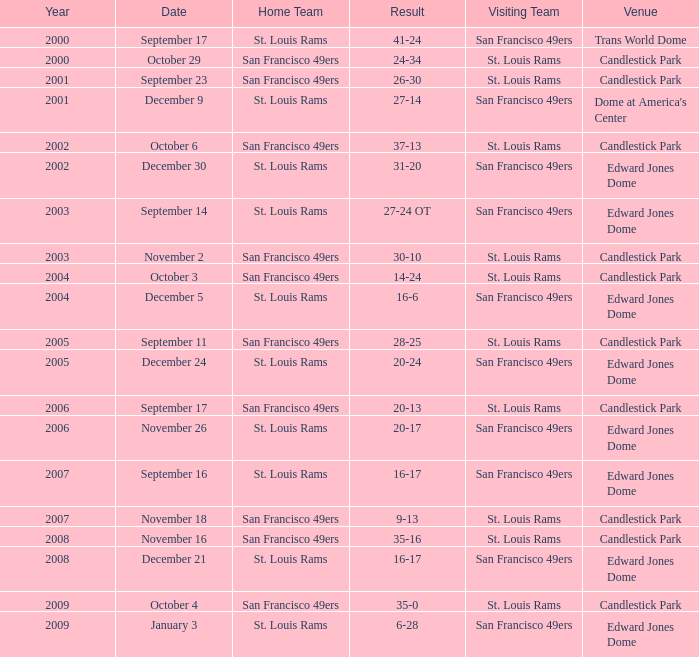What Date after 2007 had the San Francisco 49ers as the Visiting Team? December 21, January 3. 